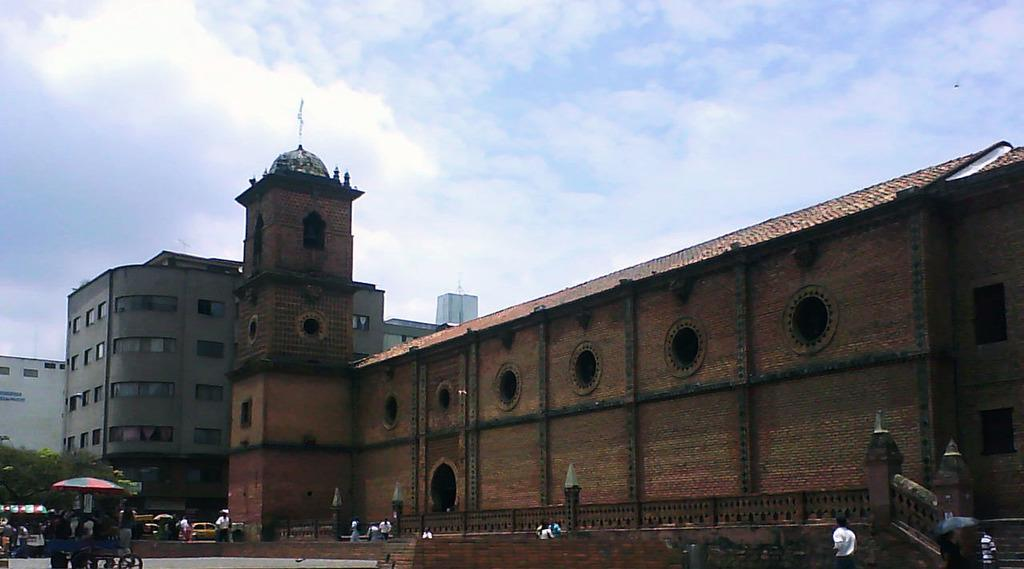What type of structures can be seen in the image? There are buildings in the image. Who or what else is present in the image? There are persons and trees in the image. What type of temporary shelter is visible in the image? There are tents in the image. How would you describe the weather based on the image? The sky is cloudy in the image, suggesting a potentially overcast or cloudy day. What type of paste is being used to style the hair of the persons in the image? There is no mention of hair or paste in the image, so it cannot be determined if any paste is being used for styling. 